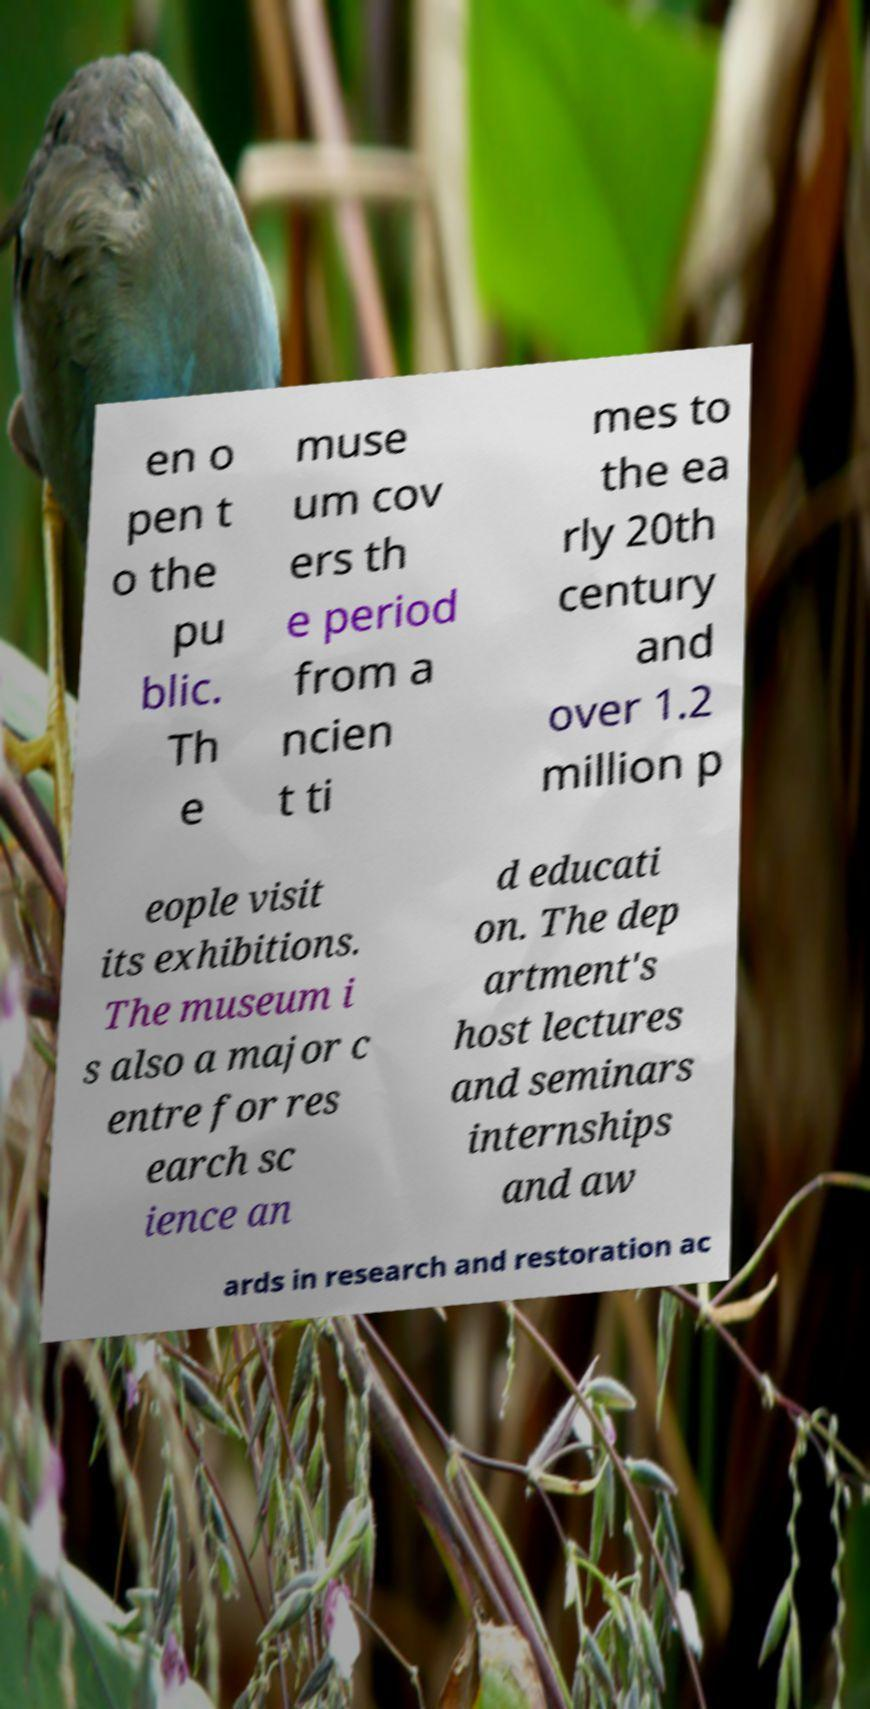Can you read and provide the text displayed in the image?This photo seems to have some interesting text. Can you extract and type it out for me? en o pen t o the pu blic. Th e muse um cov ers th e period from a ncien t ti mes to the ea rly 20th century and over 1.2 million p eople visit its exhibitions. The museum i s also a major c entre for res earch sc ience an d educati on. The dep artment's host lectures and seminars internships and aw ards in research and restoration ac 